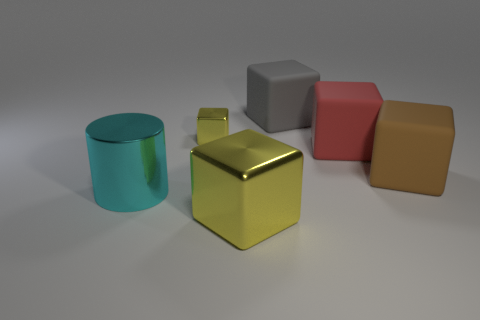Are there fewer large brown rubber blocks to the left of the big yellow metallic thing than gray metal balls? no 